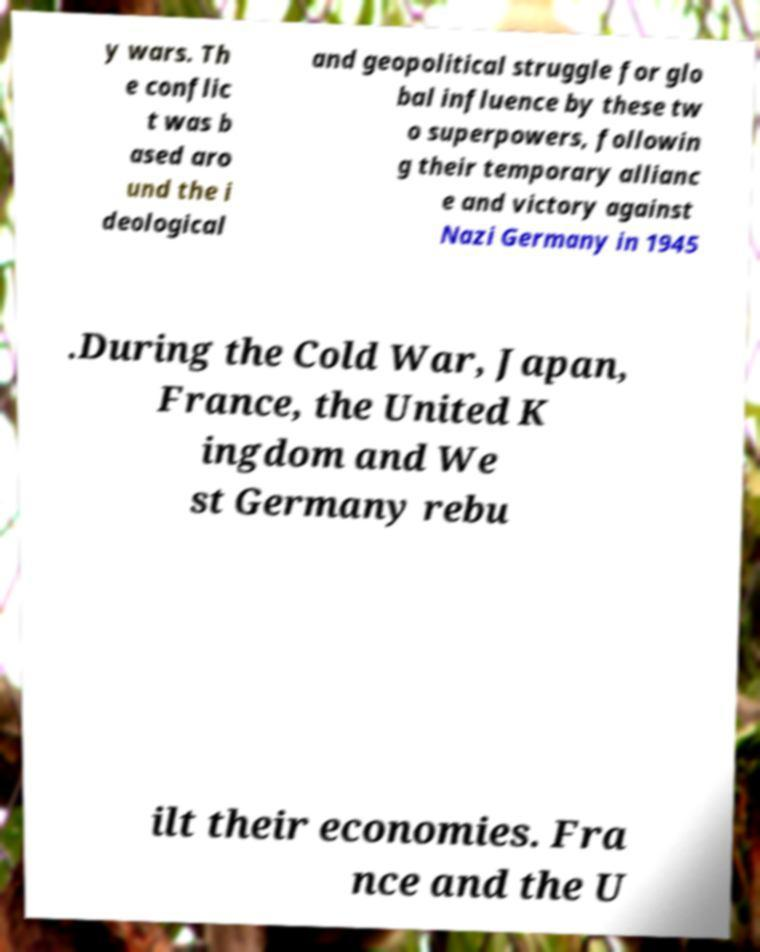There's text embedded in this image that I need extracted. Can you transcribe it verbatim? y wars. Th e conflic t was b ased aro und the i deological and geopolitical struggle for glo bal influence by these tw o superpowers, followin g their temporary allianc e and victory against Nazi Germany in 1945 .During the Cold War, Japan, France, the United K ingdom and We st Germany rebu ilt their economies. Fra nce and the U 